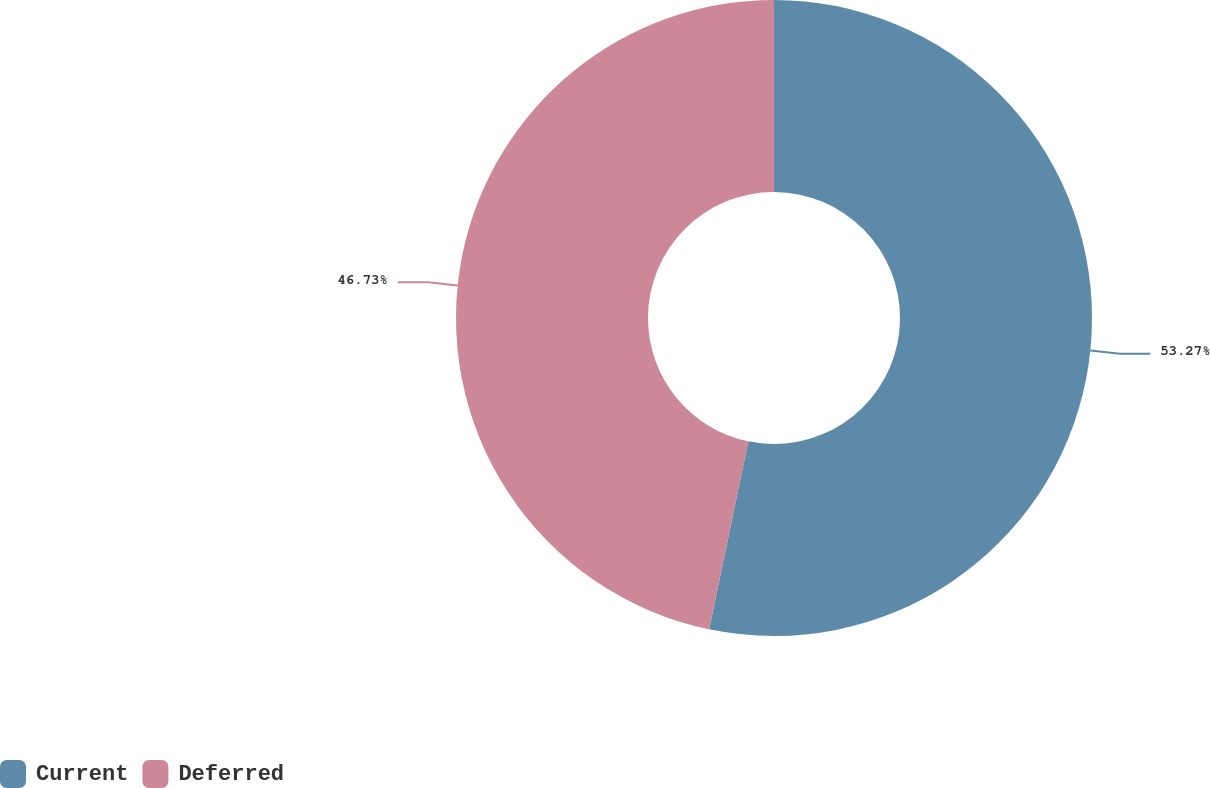Convert chart. <chart><loc_0><loc_0><loc_500><loc_500><pie_chart><fcel>Current<fcel>Deferred<nl><fcel>53.27%<fcel>46.73%<nl></chart> 